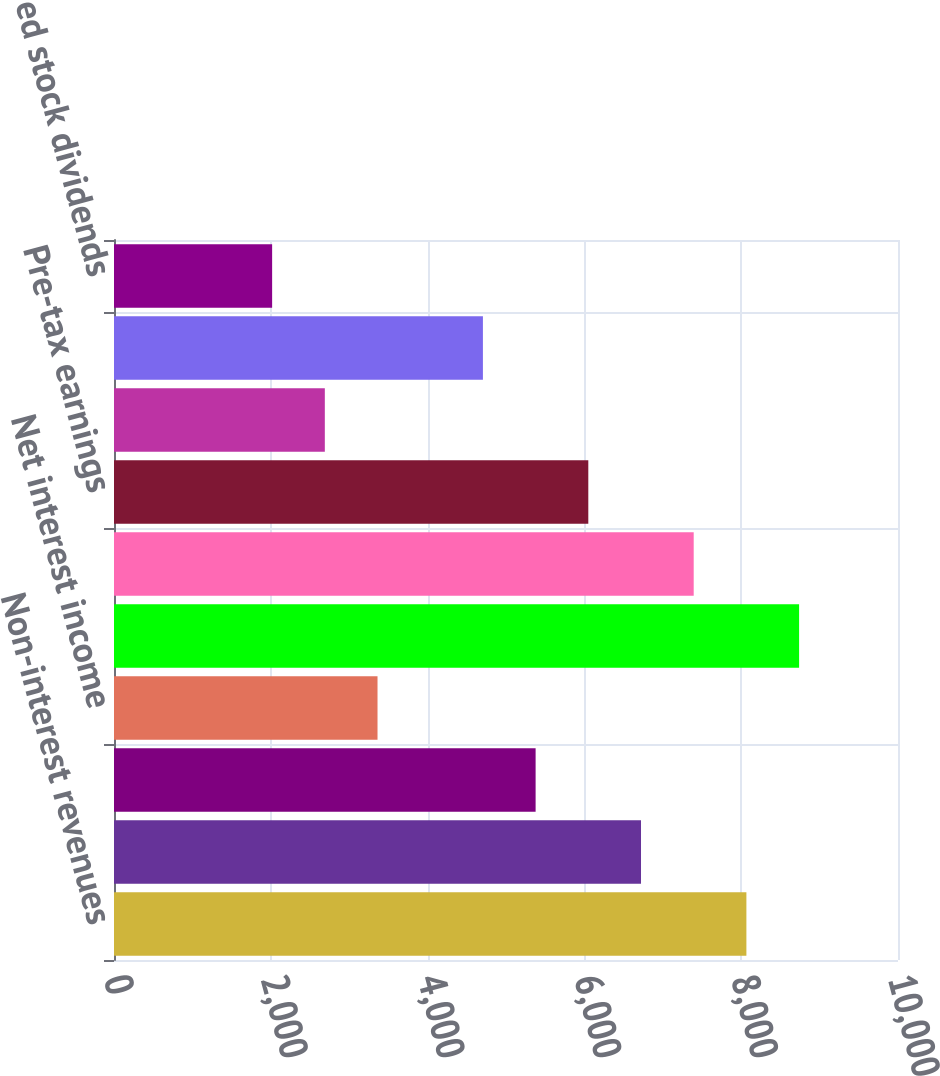Convert chart to OTSL. <chart><loc_0><loc_0><loc_500><loc_500><bar_chart><fcel>Non-interest revenues<fcel>Interest income<fcel>Interest expense<fcel>Net interest income<fcel>Net revenues including net<fcel>Operating expenses 1<fcel>Pre-tax earnings<fcel>Provision for taxes<fcel>Net earnings<fcel>Preferred stock dividends<nl><fcel>8066.3<fcel>6722<fcel>5377.7<fcel>3361.25<fcel>8738.45<fcel>7394.15<fcel>6049.85<fcel>2689.1<fcel>4705.55<fcel>2016.95<nl></chart> 